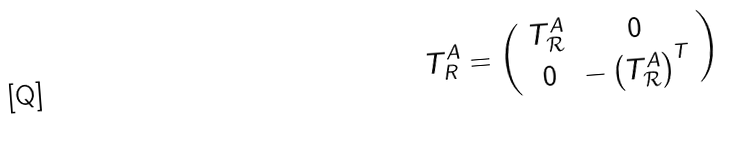Convert formula to latex. <formula><loc_0><loc_0><loc_500><loc_500>T _ { R } ^ { A } = \left ( \begin{array} { c c } { { T _ { \mathcal { R } } ^ { A } } } & { 0 } \\ { 0 } & { { - \left ( T _ { \mathcal { R } } ^ { A } \right ) ^ { T } } } \end{array} \right )</formula> 